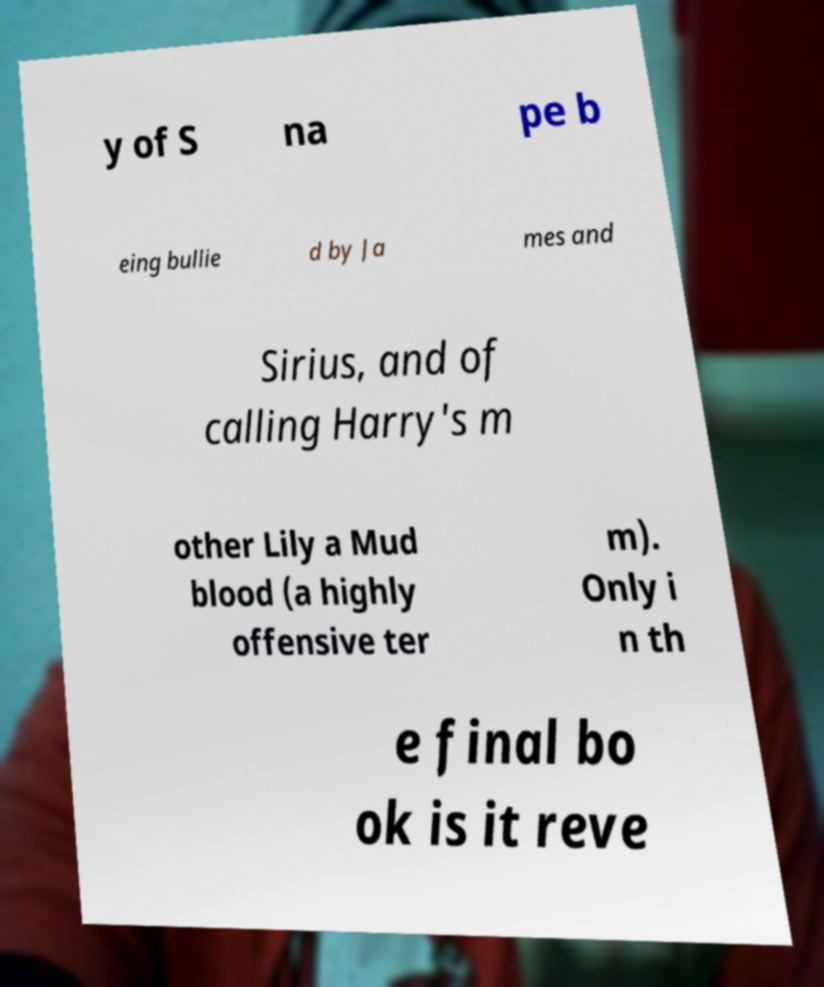For documentation purposes, I need the text within this image transcribed. Could you provide that? y of S na pe b eing bullie d by Ja mes and Sirius, and of calling Harry's m other Lily a Mud blood (a highly offensive ter m). Only i n th e final bo ok is it reve 